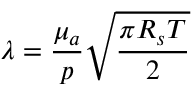<formula> <loc_0><loc_0><loc_500><loc_500>{ \lambda } = \frac { { \mu } _ { a } } { p } \sqrt { \frac { { \pi } R _ { s } T } { 2 } }</formula> 